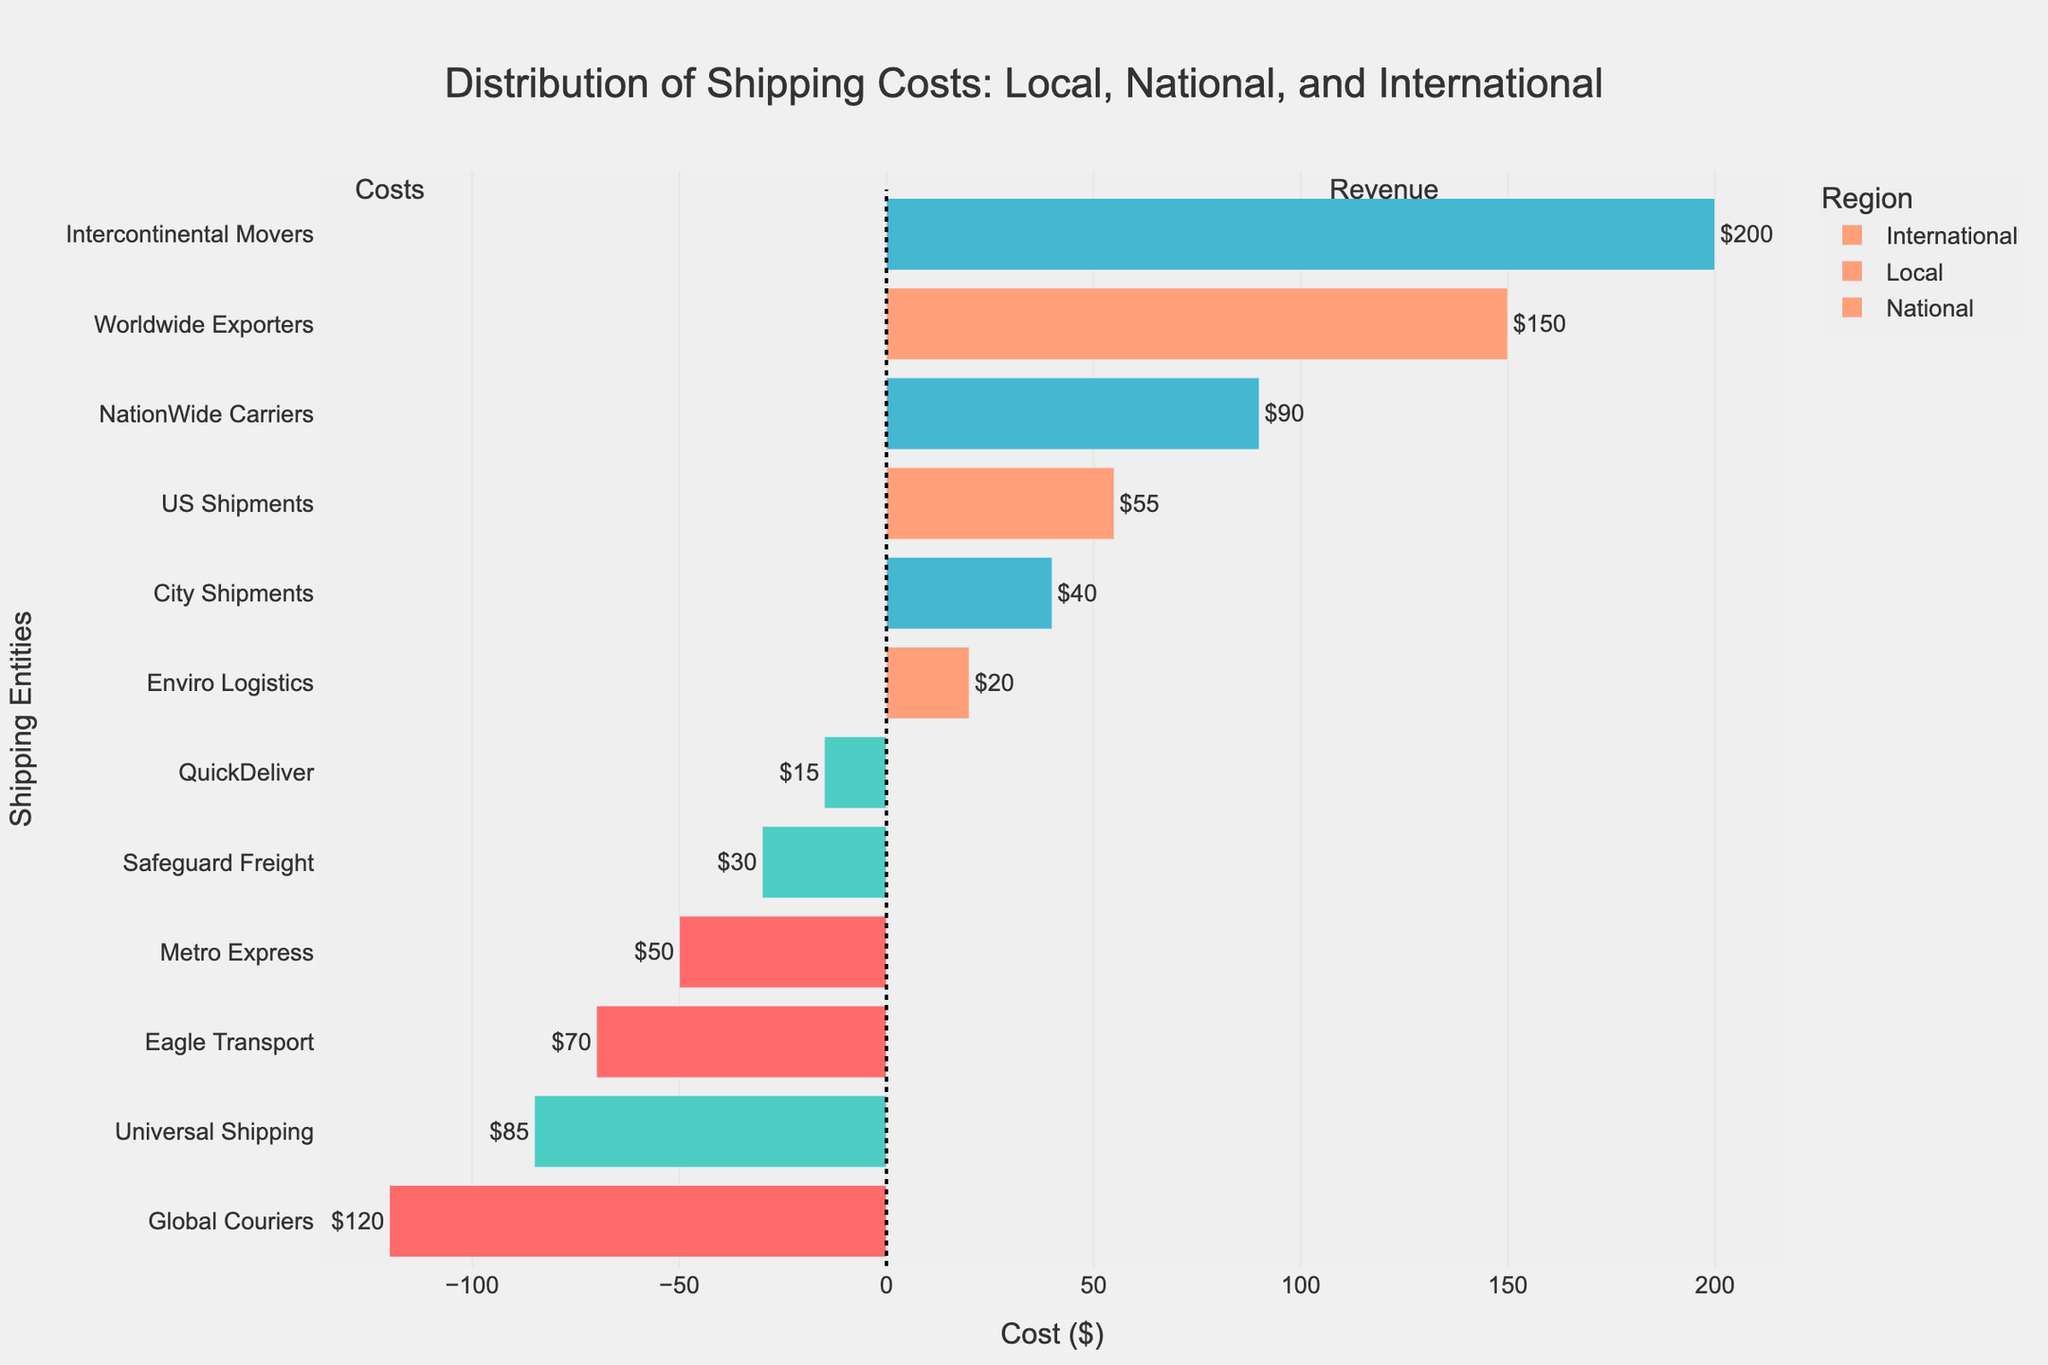Which entity has the highest shipping cost for international destinations? The bars representing the shipping costs for international destinations show 'Intercontinental Movers' with the highest positive value, which corresponds to the shipping cost.
Answer: Intercontinental Movers What is the sum of handling and insurance costs for Global Couriers? For Global Couriers, the handling cost is shown as -120 on the diverging bar chart, but its actual cost is 120. The insurance cost for international destinations by Global Couriers' is displayed as 85. Sum them up: 120 + 85 = 205.
Answer: 205 Which region has the highest customs cost? Among the customs bars, the international destination category, represented by 'Worldwide Exporters', has the highest positive value among the customs costs.
Answer: International How does the shipping cost for NationWide Carriers compare to that of Eagle Transport in national destinations? NationWide Carriers' shipping cost is shown as a positive value in the national destinations section, which is 90, while Eagle Transport's handling cost is shown as -70. Since shipping and handling costs are compared, only positive values of costs are relevant here.
Answer: Higher What is the total cost (handling, shipping, insurance, customs) for City Shipments? City Shipments only has a shipping cost. The detailed data show that this shipping cost in City Shipments is 40. Summing this up: 40.
Answer: 40 Which cost type shows the most instances of high negative values and for which entity? The handling and insurance bars show negative values. Among them, handling in international destinations shows -120 for Global Couriers and -70 for Eagle Transport. Both show high negative values for these handling costs.
Answer: Handling, Global Couriers Compare the insurance costs between local and national destinations. For local destinations, QuickDeliver is shown with an insurance cost of -15. For national destinations, Safeguard Freight has a cost of -30. -30 is less than -15, indicating lower costs (more negative) for national over local.
Answer: Lower What is the average cost for insurance in local, national, and international destinations? For local: QuickDeliver -15. For national: Safeguard Freight -30. For international: Universal Shipping -85. The average is calculated as (-15 + -30 + -85)/3 = -130/3 = -43.33.
Answer: -43.33 Which entity in local destinations has the lowest customs cost and what is that cost? Among local destination's customs costs, the only entity is Enviro Logistics. The customs cost for Enviro Logistics is shown as 20 in the chart.
Answer: Enviro Logistics, 20 